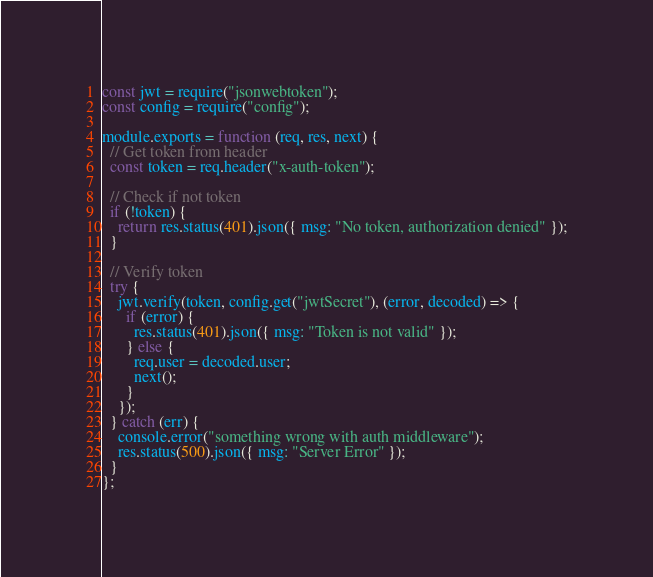Convert code to text. <code><loc_0><loc_0><loc_500><loc_500><_JavaScript_>const jwt = require("jsonwebtoken");
const config = require("config");

module.exports = function (req, res, next) {
  // Get token from header
  const token = req.header("x-auth-token");

  // Check if not token
  if (!token) {
    return res.status(401).json({ msg: "No token, authorization denied" });
  }

  // Verify token
  try {
    jwt.verify(token, config.get("jwtSecret"), (error, decoded) => {
      if (error) {
        res.status(401).json({ msg: "Token is not valid" });
      } else {
        req.user = decoded.user;
        next();
      }
    });
  } catch (err) {
    console.error("something wrong with auth middleware");
    res.status(500).json({ msg: "Server Error" });
  }
};
</code> 